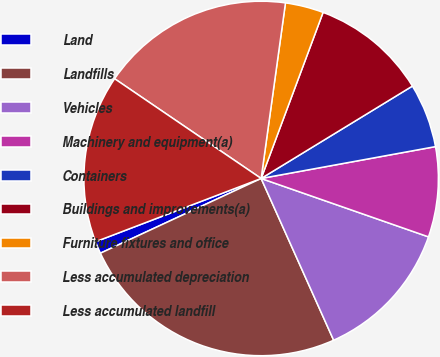Convert chart. <chart><loc_0><loc_0><loc_500><loc_500><pie_chart><fcel>Land<fcel>Landfills<fcel>Vehicles<fcel>Machinery and equipment(a)<fcel>Containers<fcel>Buildings and improvements(a)<fcel>Furniture fixtures and office<fcel>Less accumulated depreciation<fcel>Less accumulated landfill<nl><fcel>1.12%<fcel>24.78%<fcel>12.95%<fcel>8.22%<fcel>5.85%<fcel>10.59%<fcel>3.49%<fcel>17.68%<fcel>15.32%<nl></chart> 